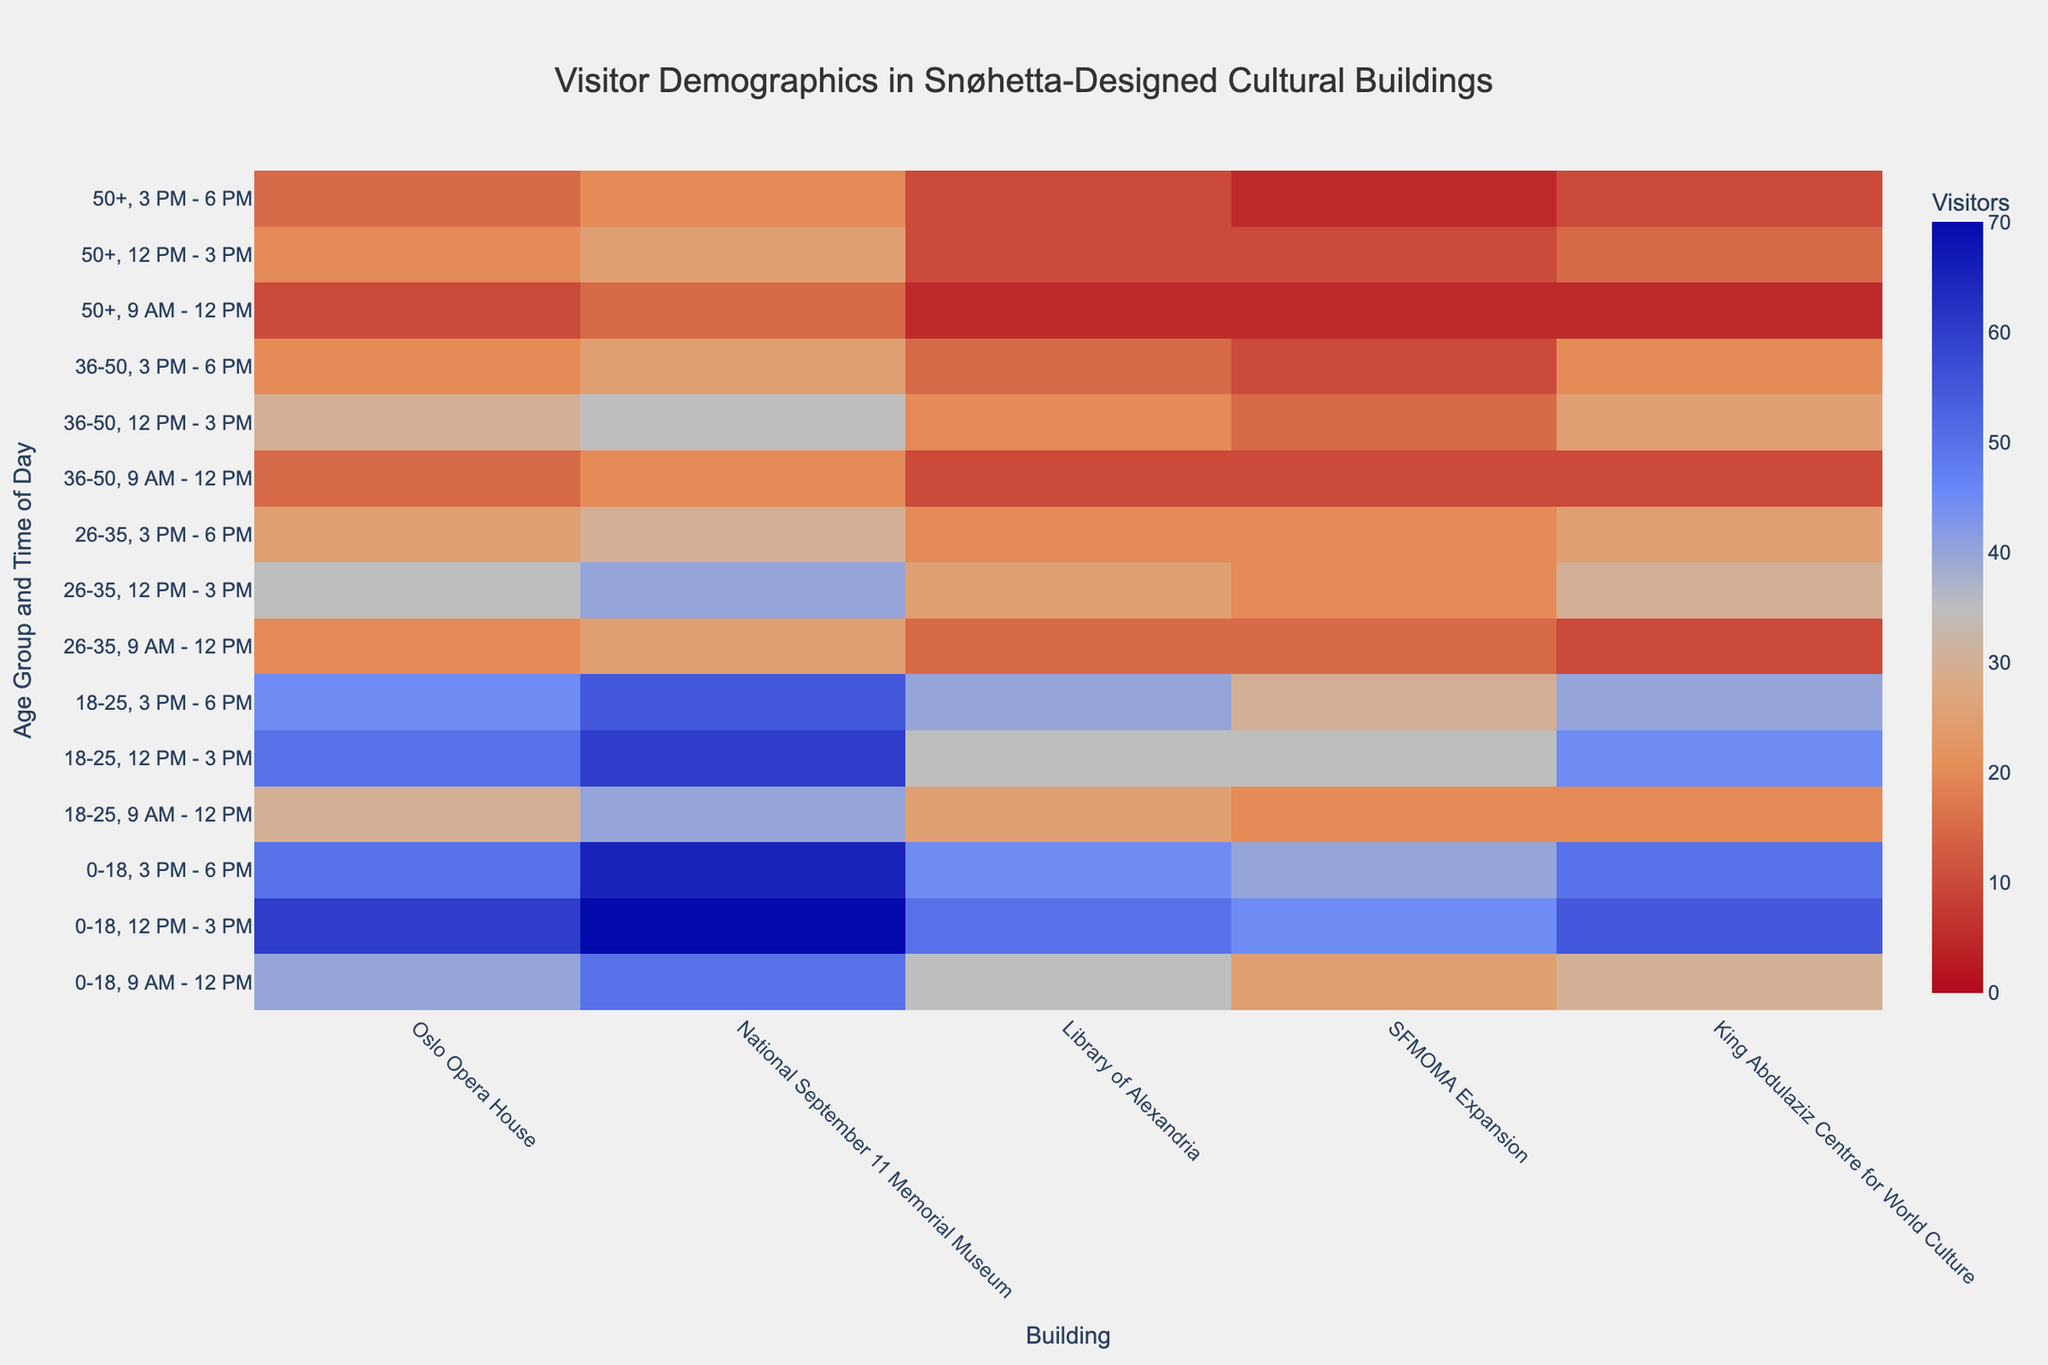What is the title of the heatmap? The title is usually located at the top and should be in larger, bold font. In this figure, the title reads "Visitor Demographics in Snøhetta-Designed Cultural Buildings".
Answer: Visitor Demographics in Snøhetta-Designed Cultural Buildings Which building has the highest number of visitors in the 0-18 age group at 12 PM - 3 PM? Locate the cell in the heatmap that corresponds to the 0-18 age group and the 12 PM - 3 PM time slot. Check which building has the highest value for this cell.
Answer: National September 11 Memorial Museum For the 18-25 age group, which time of day sees the highest number of visitors at the Oslo Opera House? Focus on the segment of the heatmap for the 18-25 age group. Compare the visitor numbers for each time of day and identify the highest value.
Answer: 12 PM - 3 PM What is the range of visitor numbers for the 26-35 age group across all buildings and times of day? Identify the smallest and largest values for the 26-35 age group across all cells in the heatmap.
Answer: 10 to 40 How does the visitor count at SFMOMA Expansion for the 50+ age group at 3 PM - 6 PM compare to the visitor count at the same building and time for the 0-18 age group? Locate the relevant cells for both age groups and compare their values. The comparison shows that the 50+ age group has 5 visitors while the 0-18 age group has 40 visitors at SFMOMA Expansion during 3 PM - 6 PM.
Answer: 40 vs 5 What is the average number of visitors for the King Abdulaziz Centre for World Culture in the 18-25 age group across all time slots? Sum the number of visitors for the 18-25 age group at King Abdulaziz Centre for World Culture across all three time slots (20 + 45 + 40) and divide by the number of time slots (3).
Answer: 35 Which time of day attracts the most visitors to the Library of Alexandria for the 36-50 age group? Compare the visitor numbers for each time slot in the 36-50 age group for the Library of Alexandria and identify the highest value.
Answer: 12 PM - 3 PM By how much does the visitor count decrease from 12 PM - 3 PM to 3 PM - 6 PM for the Oslo Opera House for the 0-18 age group? Subtract the visitor count at 3 PM - 6 PM from the count at 12 PM - 3 PM for the 0-18 age group at the Oslo Opera House (60 - 50).
Answer: 10 Which age group has the lowest average visitor count across all buildings and times of day? Calculate the average visitor count for each age group by summing their values across all buildings and times of day and dividing by the total number of data points for each group. Identify the group with the lowest average.
Answer: 50+ What is the most common color used in cells indicating visitor counts between 30 and 40? Observe the heatmap's color gradient and identify the most common color used in the cells with values within the given range (30-40).
Answer: A shade between light brown and tan 